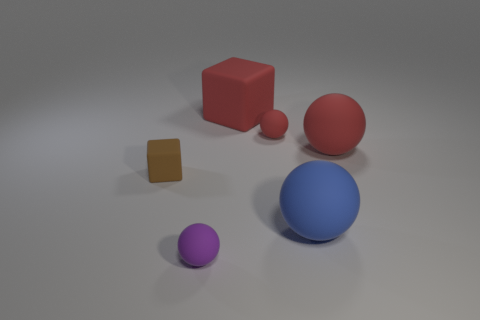There is a small rubber ball right of the big red matte block; how many large matte blocks are to the right of it?
Your answer should be very brief. 0. Is there any other thing that has the same shape as the brown rubber thing?
Your answer should be very brief. Yes. Does the big ball behind the big blue matte object have the same color as the small thing that is behind the tiny brown matte cube?
Give a very brief answer. Yes. Are there fewer tiny cyan metal balls than blue rubber balls?
Make the answer very short. Yes. The tiny rubber thing to the left of the purple rubber object right of the small brown matte cube is what shape?
Your answer should be very brief. Cube. Is there any other thing that is the same size as the blue thing?
Your answer should be compact. Yes. What shape is the big rubber thing to the left of the tiny rubber object that is behind the matte block that is in front of the large red matte block?
Make the answer very short. Cube. What number of objects are either small spheres that are in front of the small brown rubber object or small spheres behind the purple matte object?
Ensure brevity in your answer.  2. There is a blue object; is it the same size as the matte block behind the brown matte object?
Offer a terse response. Yes. Is the tiny ball that is left of the big block made of the same material as the ball to the right of the big blue thing?
Ensure brevity in your answer.  Yes. 